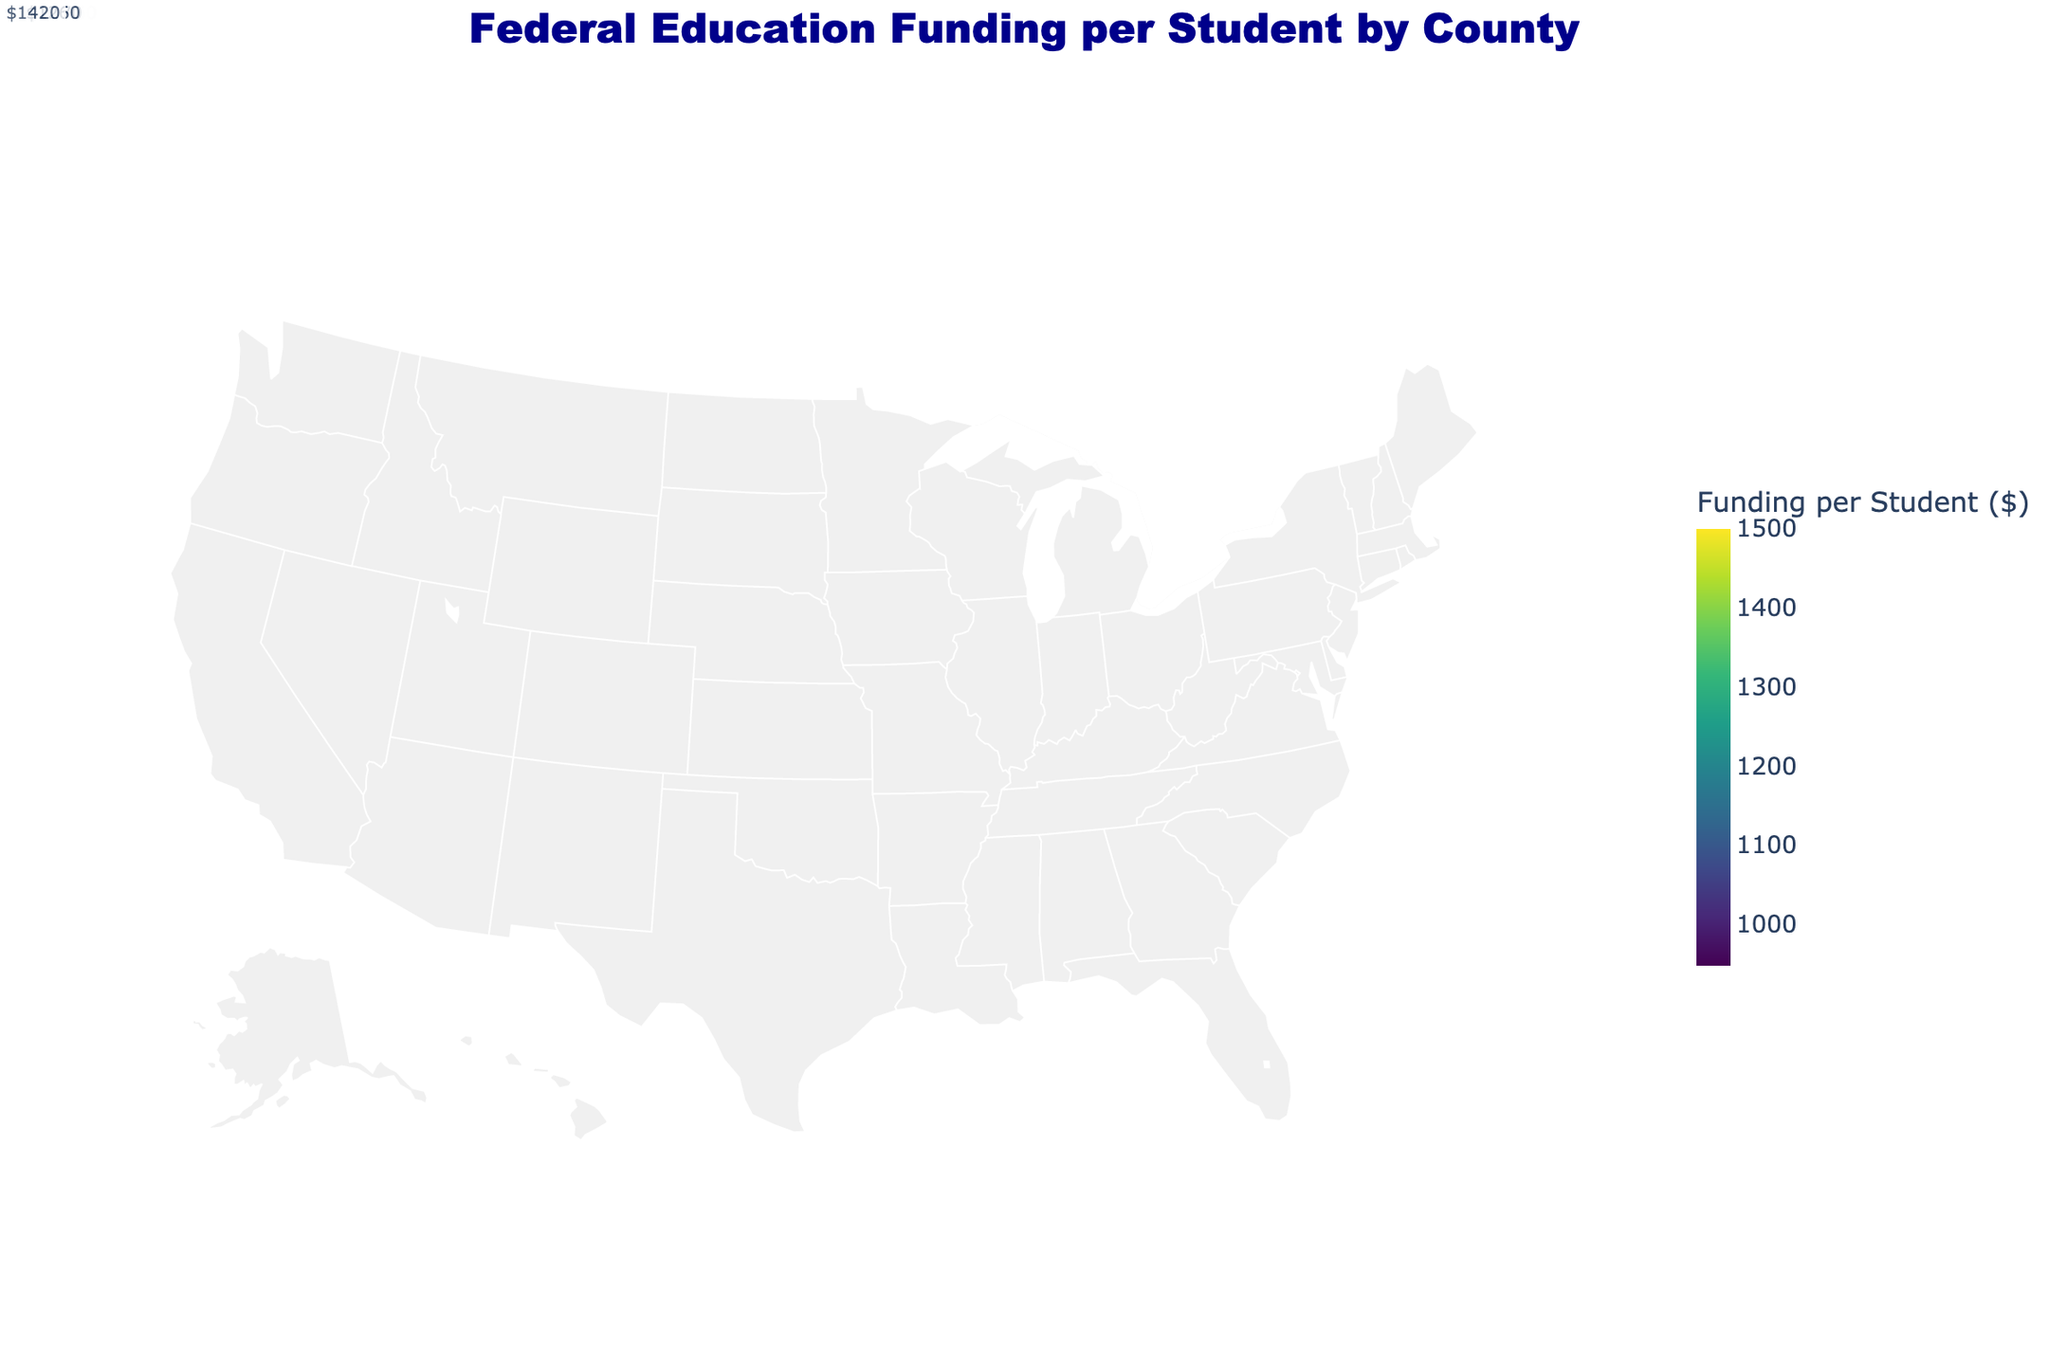What is the title of the figure? The title is located at the top of the figure in large, bold font. It serves to inform the viewer about the content of the visual.
Answer: Federal Education Funding per Student by County Which county receives the highest federal education funding per student? By hovering over the counties or referring to the color scale, we can identify which county has the highest funding per student. The county with the darkest color has the highest funding.
Answer: New York, New York Which state has the most counties listed in the figure? By counting the number of counties for each state, we determine which has the highest count. California appears most frequently.
Answer: California What is the average federal education funding per student for the counties in Texas? We calculate the mean by summing the funding values for Texas counties and dividing by the number of Texas counties listed. (980 + 990 + 970 + 960) / 4 = 975.
Answer: 975 How does the federal education funding per student in Middlesex, Massachusetts compare to Miami-Dade, Florida? We compare the funding amounts directly. Middlesex has 1320, while Miami-Dade has 1300.
Answer: Middlesex, Massachusetts receives more Identify two counties with a funding amount closest to 1150 dollars per student. By reviewing the color scale or annotations on the map, we find counties with funding near 1150. San Diego, California (1150), and Riverside, California (1180).
Answer: San Diego and Riverside What's the federal education funding range for the counties listed in Florida? We find the minimum and maximum values among Florida counties. Broward is at 1270, Palm Beach at 1260, Miami-Dade at 1300. Range is 1260-1300.
Answer: 1260 to 1300 What is the total number of counties included in the figure? We count each unique county represented in the data set.
Answer: 24 Which state has the highest average federal funding per student, considering only the states represented? Calculate the average for each state and compare. New York: (1400 + 1420 + 1450) / 3 = 1423.33, indicating New York.
Answer: New York 